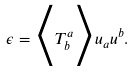<formula> <loc_0><loc_0><loc_500><loc_500>\epsilon = \Big < T ^ { a } _ { b } \Big > u _ { a } u ^ { b } .</formula> 